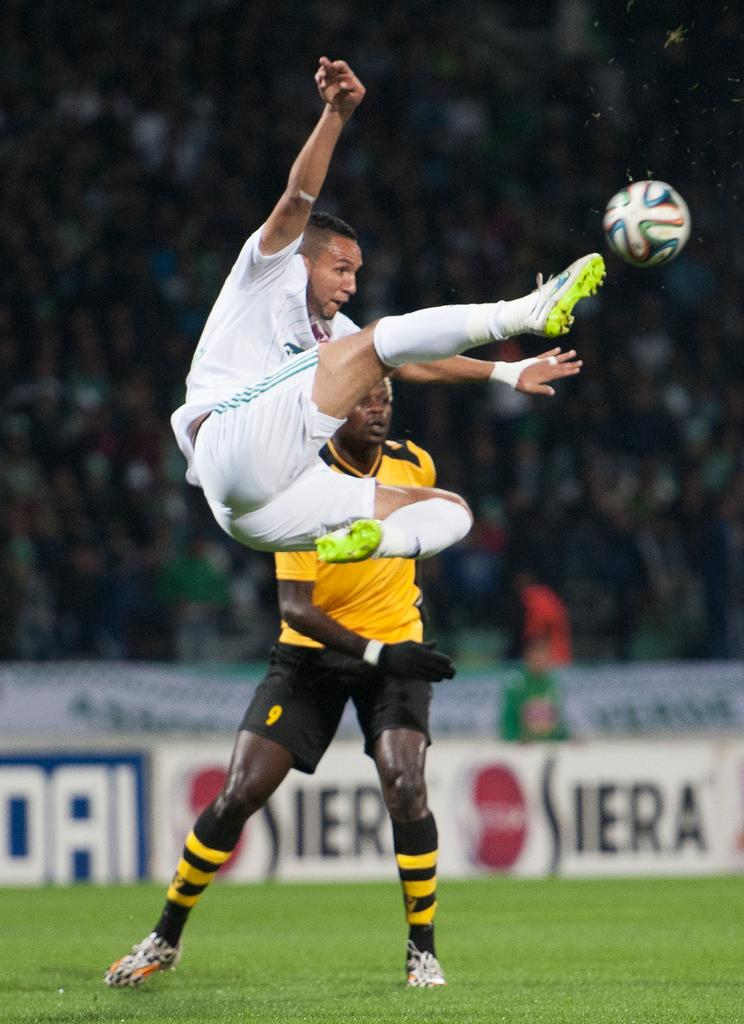How many people are in the image? There are two men in the image. What activity are the men engaged in? The men are playing football. What can be seen in the background of the image? There is a banner visible in the background of the image. What type of apparel is the stick wearing in the image? There is no stick or apparel present in the image. What is the weather like during the football game in the image? The provided facts do not mention the weather, so we cannot determine the weather conditions from the image. 